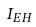Convert formula to latex. <formula><loc_0><loc_0><loc_500><loc_500>I _ { E H }</formula> 